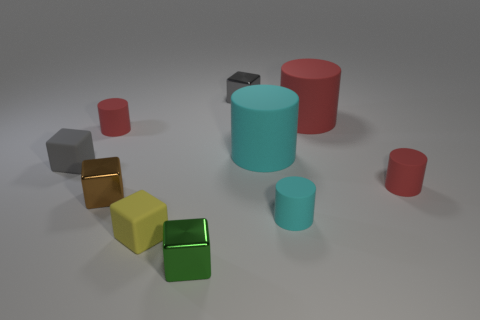Subtract all cyan balls. How many red cylinders are left? 3 Subtract all big cyan matte cylinders. How many cylinders are left? 4 Subtract 1 blocks. How many blocks are left? 4 Subtract all green blocks. How many blocks are left? 4 Subtract all red blocks. Subtract all gray spheres. How many blocks are left? 5 Add 4 small purple metal cubes. How many small purple metal cubes exist? 4 Subtract 0 cyan spheres. How many objects are left? 10 Subtract all purple blocks. Subtract all small green metal blocks. How many objects are left? 9 Add 2 big cyan rubber objects. How many big cyan rubber objects are left? 3 